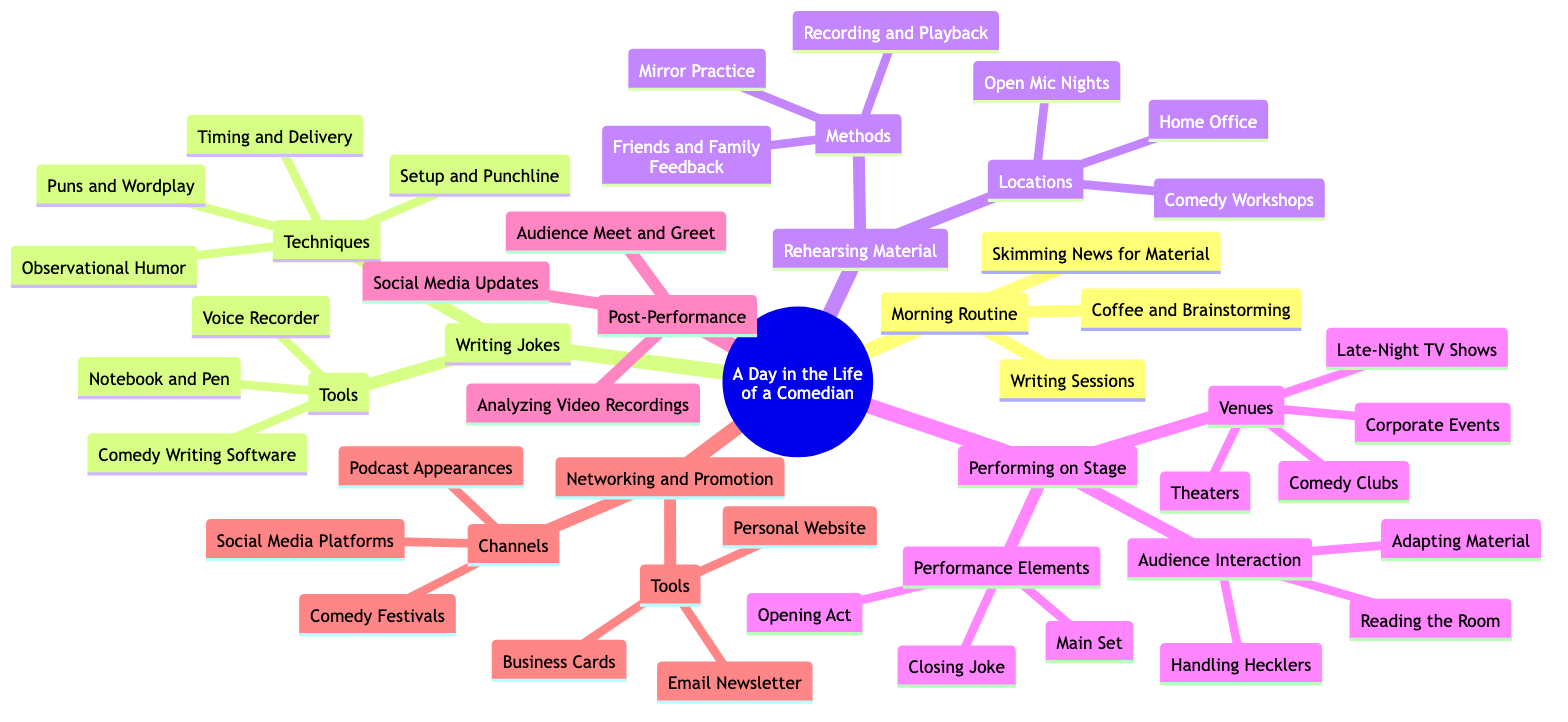What is the main topic of the diagram? The title at the top of the diagram clearly states the main topic, which encompasses the entire map and the focus of the content presented.
Answer: A Day in the Life of a Comedian How many subtopics are there? By counting the distinct groups under the main topic, we can see that there are six clear subtopics listed in the diagram.
Answer: 6 What technique is used for writing jokes? The subtopic "Writing Jokes" has a section labeled "Techniques," which includes specific methods used in creating jokes. Observational Humor is one of the techniques listed.
Answer: Observational Humor What are two venues where comedians perform? The subtopic "Performing on Stage" includes a list of venues, and by selecting any two from that list provides a quick answer. Comedy Clubs and Theaters are both mentioned.
Answer: Comedy Clubs, Theaters What activity follows performing on stage? By analyzing the diagram's flow, after the "Performing on Stage" subtopic, the next subtopic is "Post-Performance," indicating the activities that occur afterwards.
Answer: Audience Meet and Greet How does a comedian handle hecklers? From the audience interaction section under "Performing on Stage," we can see that "Handling Hecklers" is specifically about dealing with interruptions during a performance.
Answer: Handling Hecklers What is one tool used for writing jokes? In the "Writing Jokes" section, under the "Tools" category, various items are listed. One of those tools is "Notebook and Pen."
Answer: Notebook and Pen How many methods are there for rehearsing material? The "Rehearsing Material" subtopic contains three methods for rehearsal. Counting them gives us the number we're looking for.
Answer: 3 What are two channels for networking and promotion? The subtopic "Networking and Promotion" lists several channels. By selecting any two from that list, like Social Media Platforms and Comedy Festivals, we can answer the question effectively.
Answer: Social Media Platforms, Comedy Festivals 